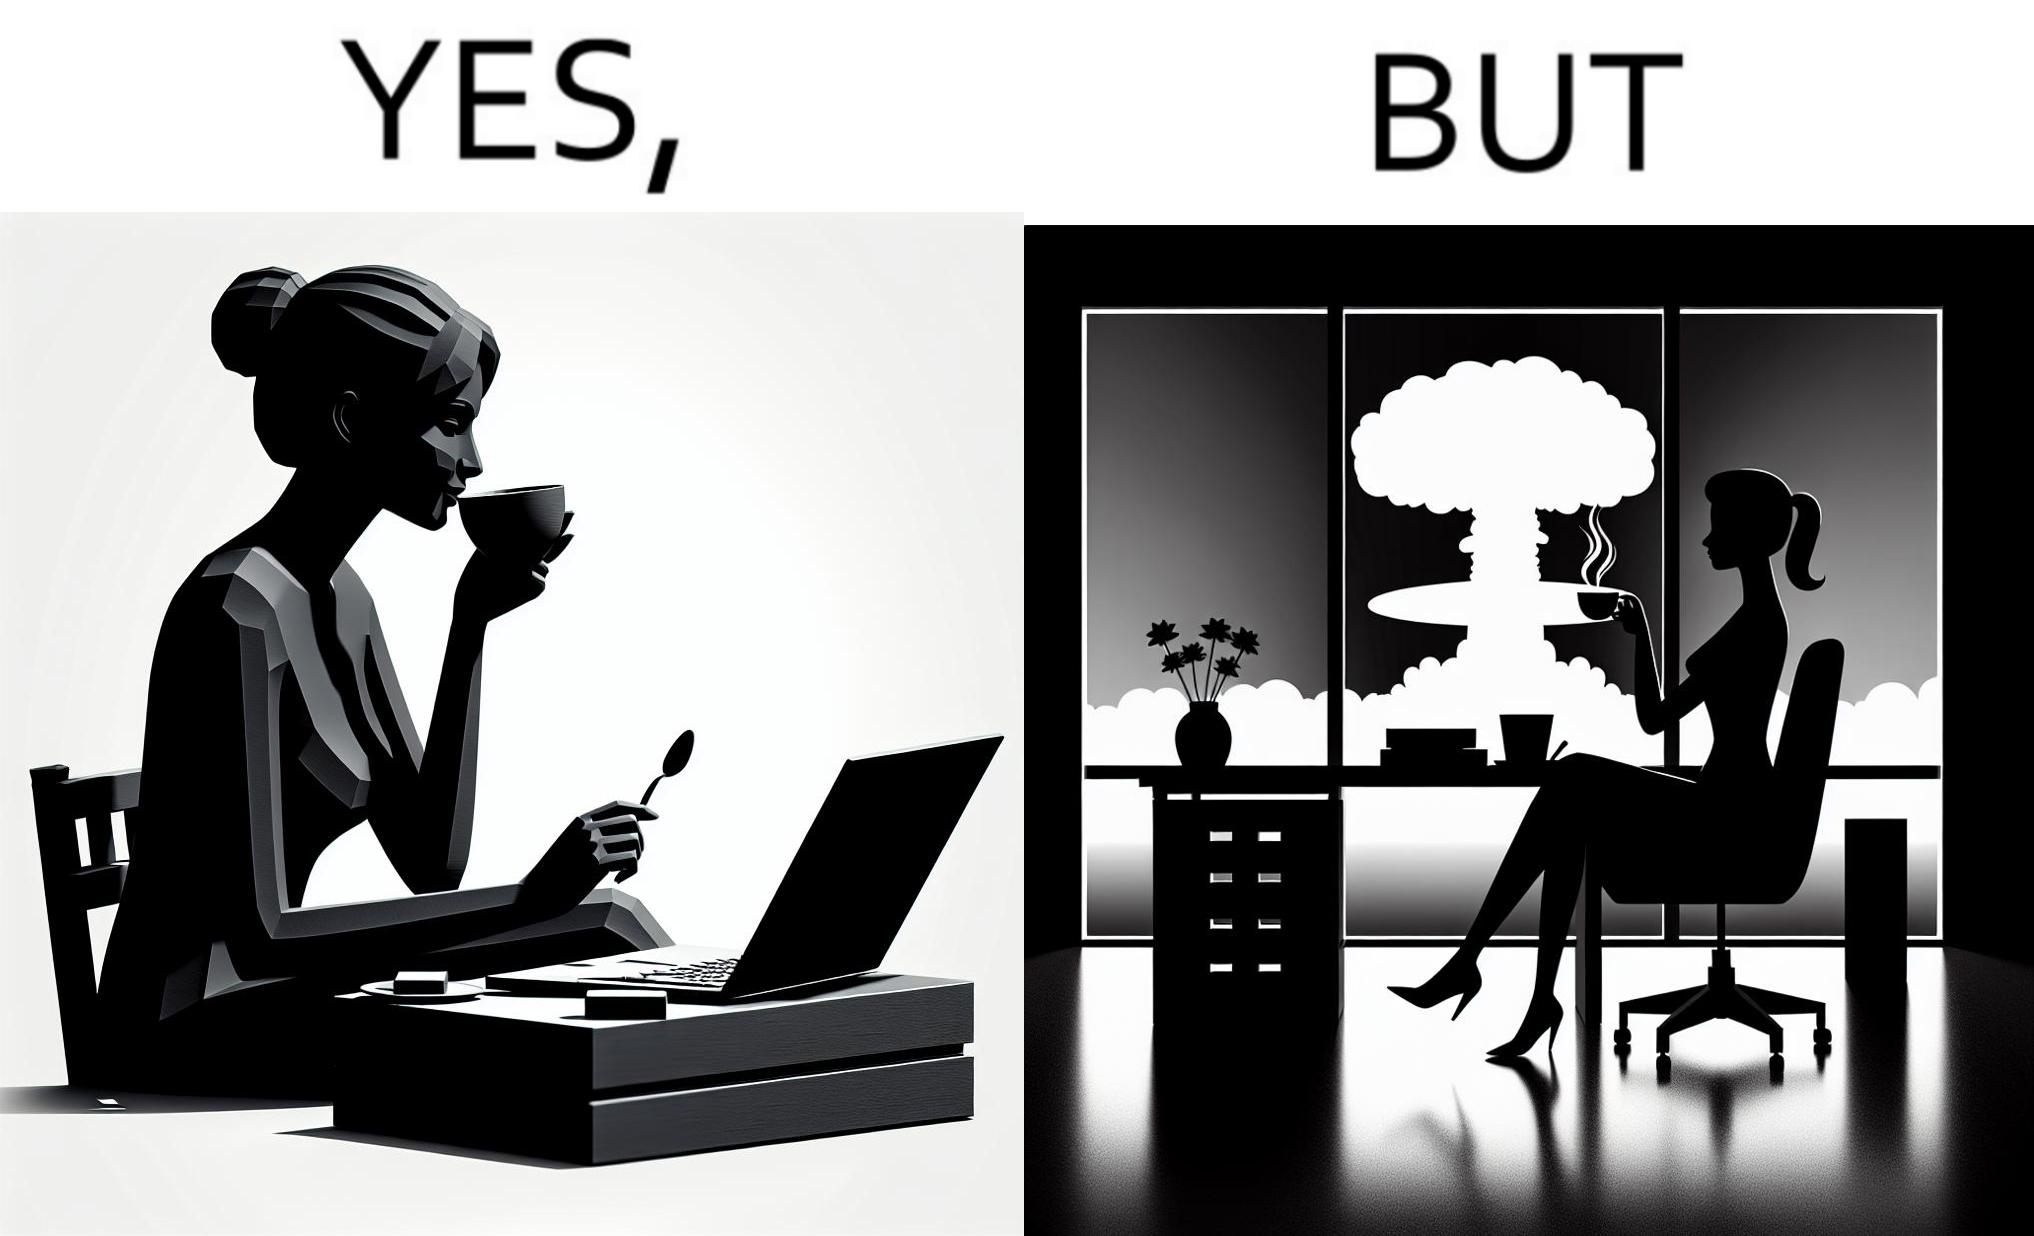Does this image contain satire or humor? Yes, this image is satirical. 